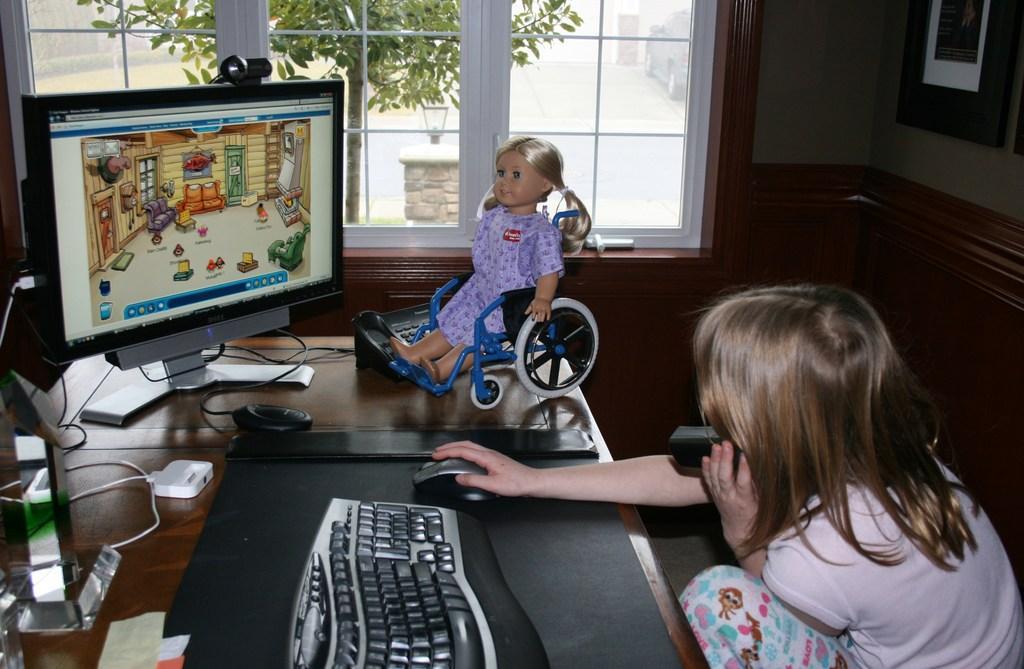Describe this image in one or two sentences. This picture shows a girl seated and holding a mobile phone her hand and we see a computer and her other hand on the mouse we see a tree and a toy 